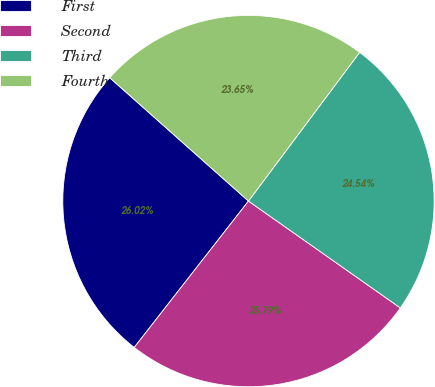<chart> <loc_0><loc_0><loc_500><loc_500><pie_chart><fcel>First<fcel>Second<fcel>Third<fcel>Fourth<nl><fcel>26.02%<fcel>25.79%<fcel>24.54%<fcel>23.65%<nl></chart> 